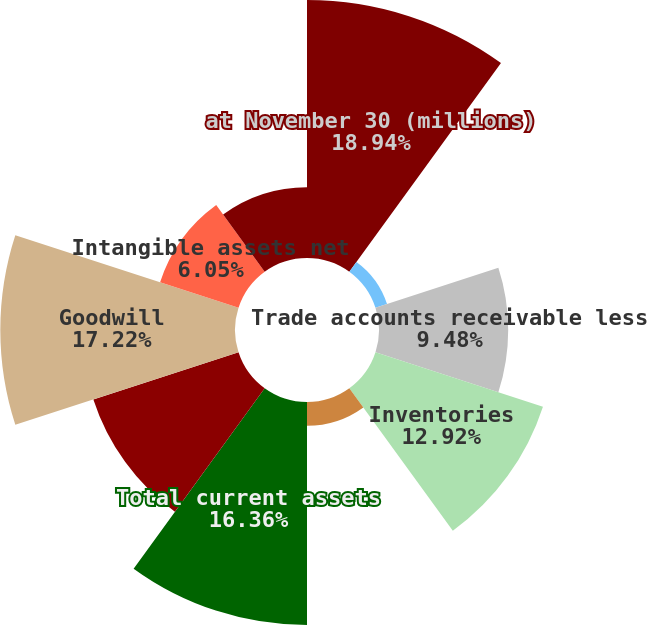Convert chart to OTSL. <chart><loc_0><loc_0><loc_500><loc_500><pie_chart><fcel>at November 30 (millions)<fcel>Cash and cash equivalents<fcel>Trade accounts receivable less<fcel>Inventories<fcel>Prepaid expenses and other<fcel>Total current assets<fcel>Property plant and equipment<fcel>Goodwill<fcel>Intangible assets net<fcel>Investments and other assets<nl><fcel>18.93%<fcel>0.89%<fcel>9.48%<fcel>12.92%<fcel>1.75%<fcel>16.36%<fcel>11.2%<fcel>17.22%<fcel>6.05%<fcel>5.19%<nl></chart> 